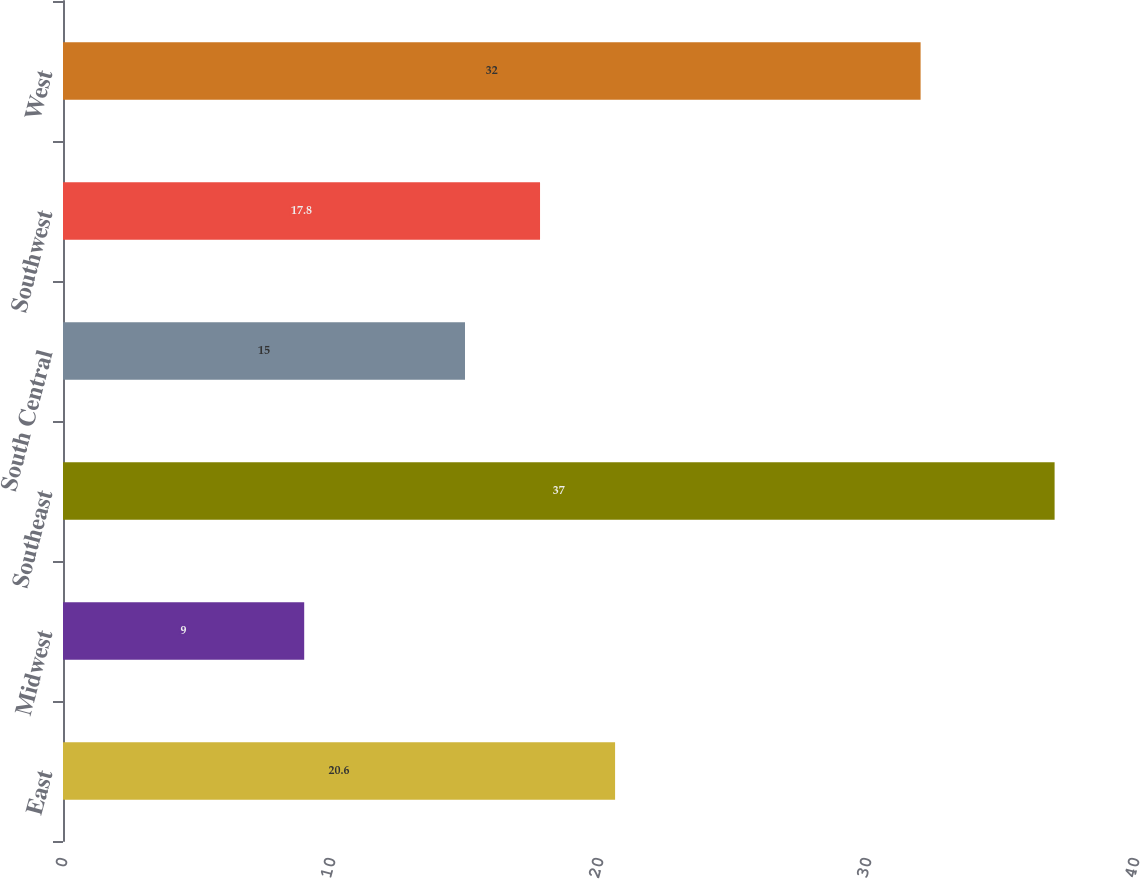<chart> <loc_0><loc_0><loc_500><loc_500><bar_chart><fcel>East<fcel>Midwest<fcel>Southeast<fcel>South Central<fcel>Southwest<fcel>West<nl><fcel>20.6<fcel>9<fcel>37<fcel>15<fcel>17.8<fcel>32<nl></chart> 